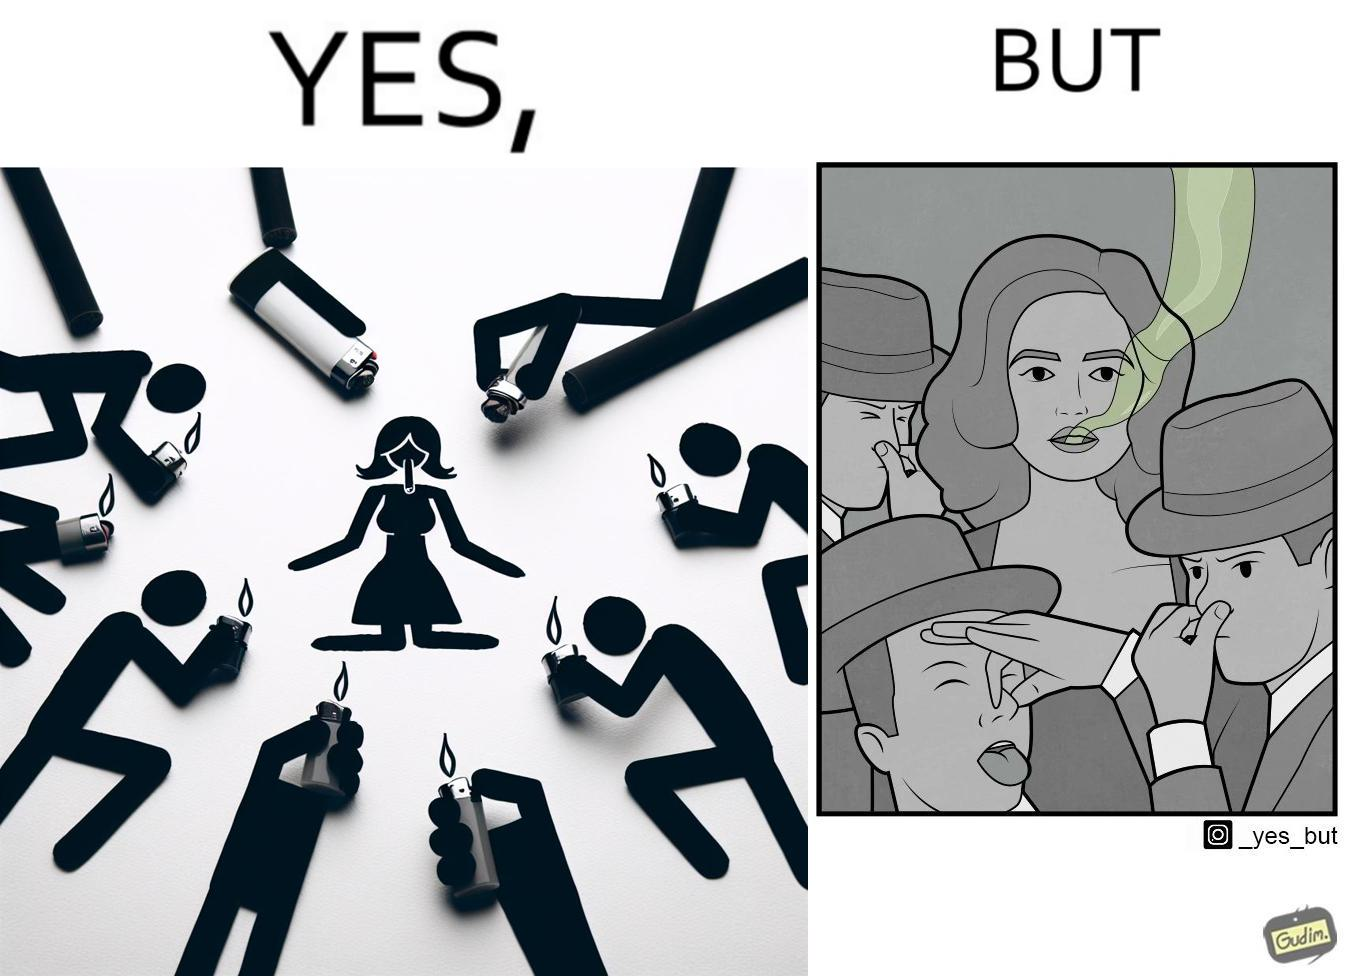Describe what you see in this image. The image is ironical, as people seem to be holding lighters to light up a woman's cigarette at an attempt to probably  impress her, while showing that the very same people are holding their noses on account of what appears to be bad smell coming out of the woman's mouth. 